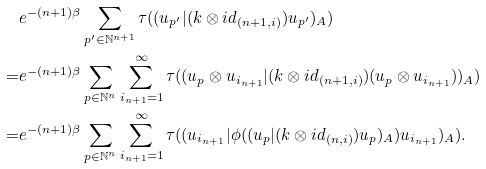<formula> <loc_0><loc_0><loc_500><loc_500>& e ^ { - ( n + 1 ) \beta } \sum _ { { p } ^ { \prime } \in { \mathbb { N } } ^ { n + 1 } } \tau ( ( { u } _ { { p } ^ { \prime } } | ( k \otimes i d _ { ( n + 1 , i ) } ) { u } _ { { p } ^ { \prime } } ) _ { A } ) \\ = & e ^ { - ( n + 1 ) \beta } \sum _ { { p } \in { \mathbb { N } } ^ { n } } \sum _ { i _ { n + 1 } = 1 } ^ { \infty } \tau ( ( { u } _ { p } \otimes u _ { i _ { n + 1 } } | ( k \otimes i d _ { ( n + 1 , i ) } ) ( { u } _ { p } \otimes u _ { i _ { n + 1 } } ) ) _ { A } ) \\ = & e ^ { - ( n + 1 ) \beta } \sum _ { { p } \in { \mathbb { N } } ^ { n } } \sum _ { i _ { n + 1 } = 1 } ^ { \infty } \tau ( ( u _ { i _ { n + 1 } } | \phi ( ( { u } _ { p } | ( k \otimes i d _ { ( n , i ) } ) { u } _ { p } ) _ { A } ) u _ { i _ { n + 1 } } ) _ { A } ) .</formula> 